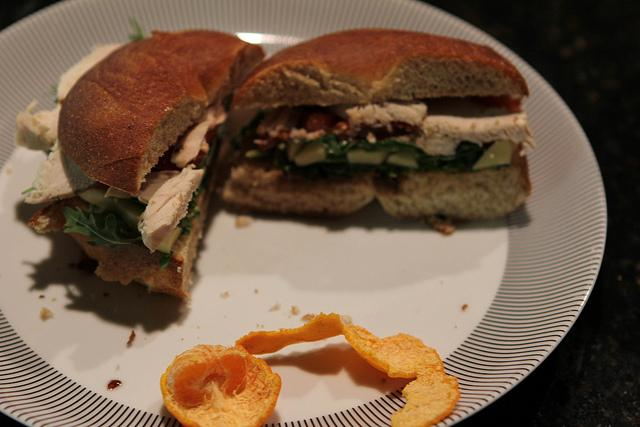Which part of this meal has a small portion? Please explain your reasoning. chips. There's some chips on the plate. 